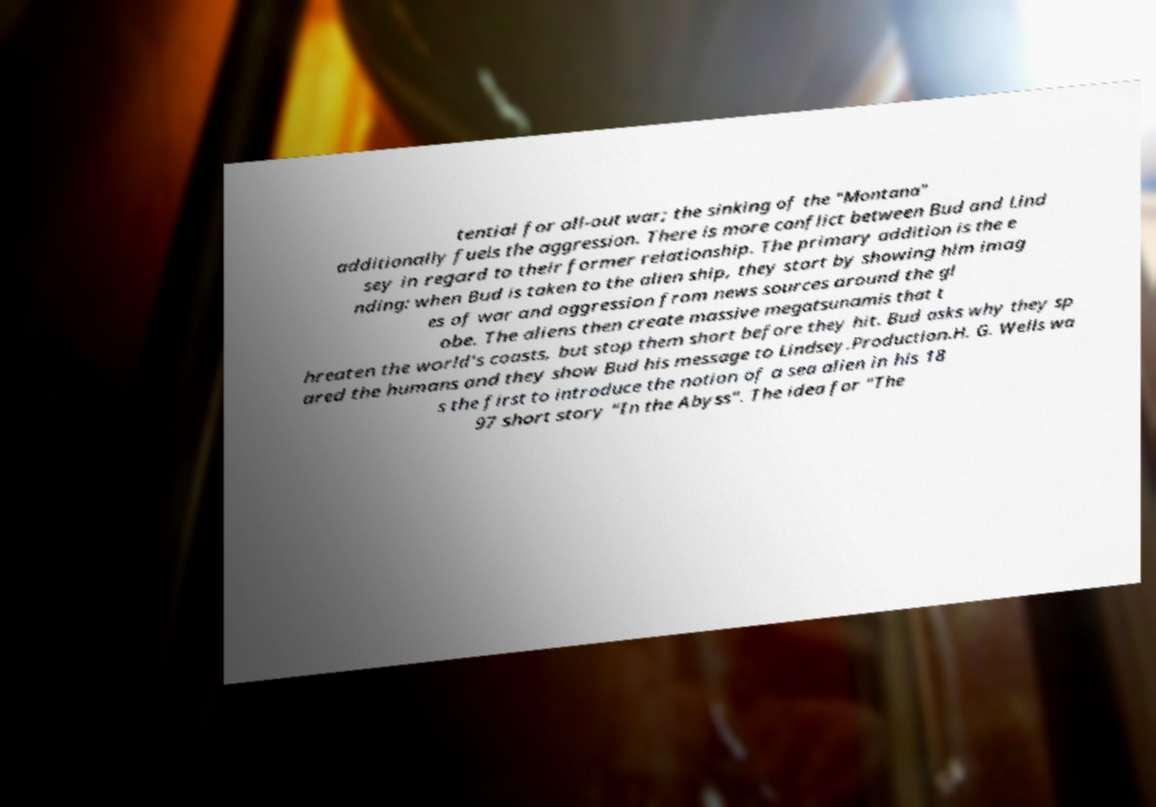Could you assist in decoding the text presented in this image and type it out clearly? tential for all-out war; the sinking of the "Montana" additionally fuels the aggression. There is more conflict between Bud and Lind sey in regard to their former relationship. The primary addition is the e nding: when Bud is taken to the alien ship, they start by showing him imag es of war and aggression from news sources around the gl obe. The aliens then create massive megatsunamis that t hreaten the world's coasts, but stop them short before they hit. Bud asks why they sp ared the humans and they show Bud his message to Lindsey.Production.H. G. Wells wa s the first to introduce the notion of a sea alien in his 18 97 short story "In the Abyss". The idea for "The 